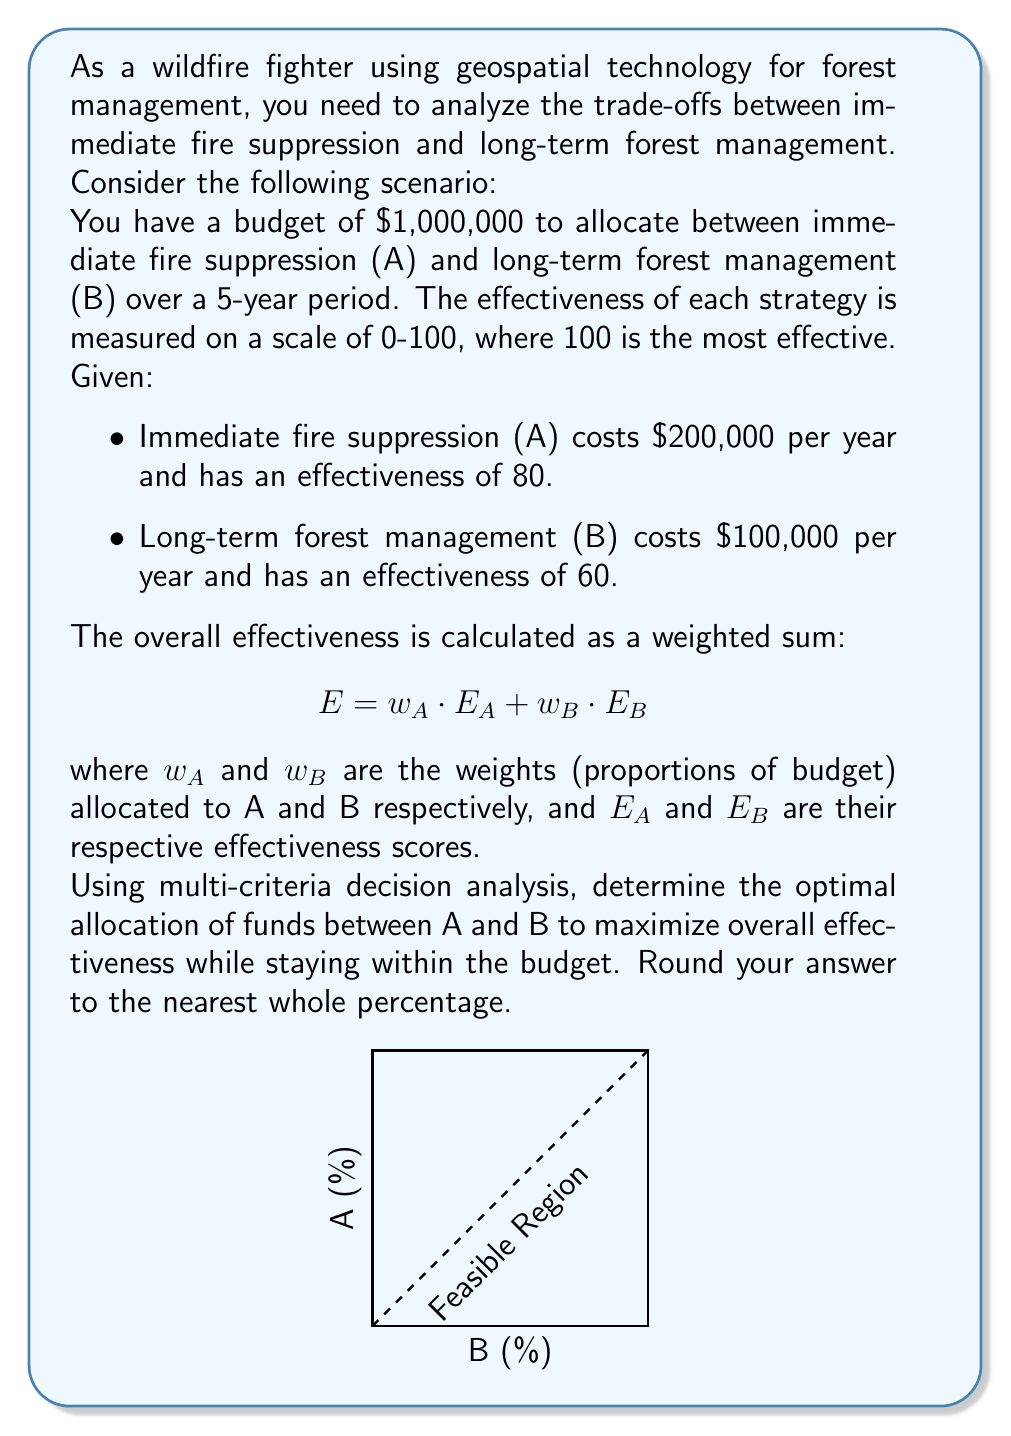Show me your answer to this math problem. Let's approach this step-by-step:

1) First, we need to set up our constraints:
   - Total budget: $1,000,000 over 5 years
   - A costs $200,000/year, B costs $100,000/year

2) Let x be the number of years we fully fund A, and y be the number of years we fully fund B:
   $$ 200,000x + 100,000y \leq 1,000,000 $$
   Simplifying: $$ 2x + y \leq 10 $$

3) We want to maximize: $$ E = \frac{x}{5} \cdot 80 + \frac{y}{5} \cdot 60 $$

4) This is a linear programming problem. The optimal solution will be at one of the corner points of the feasible region.

5) The corner points are:
   (0,10), (5,0), and (4,2)

6) Let's calculate E for each point:
   - (0,10): $E = 0 \cdot 80 + 1 \cdot 60 = 60$
   - (5,0): $E = 1 \cdot 80 + 0 \cdot 60 = 80$
   - (4,2): $E = \frac{4}{5} \cdot 80 + \frac{2}{5} \cdot 60 = 88$

7) The maximum E is at (4,2), which means:
   - 4 years of full funding for A
   - 2 years of full funding for B

8) To get the percentage allocation:
   A: $\frac{4 \cdot 200,000}{1,000,000} = 0.8$ or 80%
   B: $\frac{2 \cdot 100,000}{1,000,000} = 0.2$ or 20%

Therefore, the optimal allocation is 80% to A (immediate fire suppression) and 20% to B (long-term forest management).
Answer: 80% to A, 20% to B 